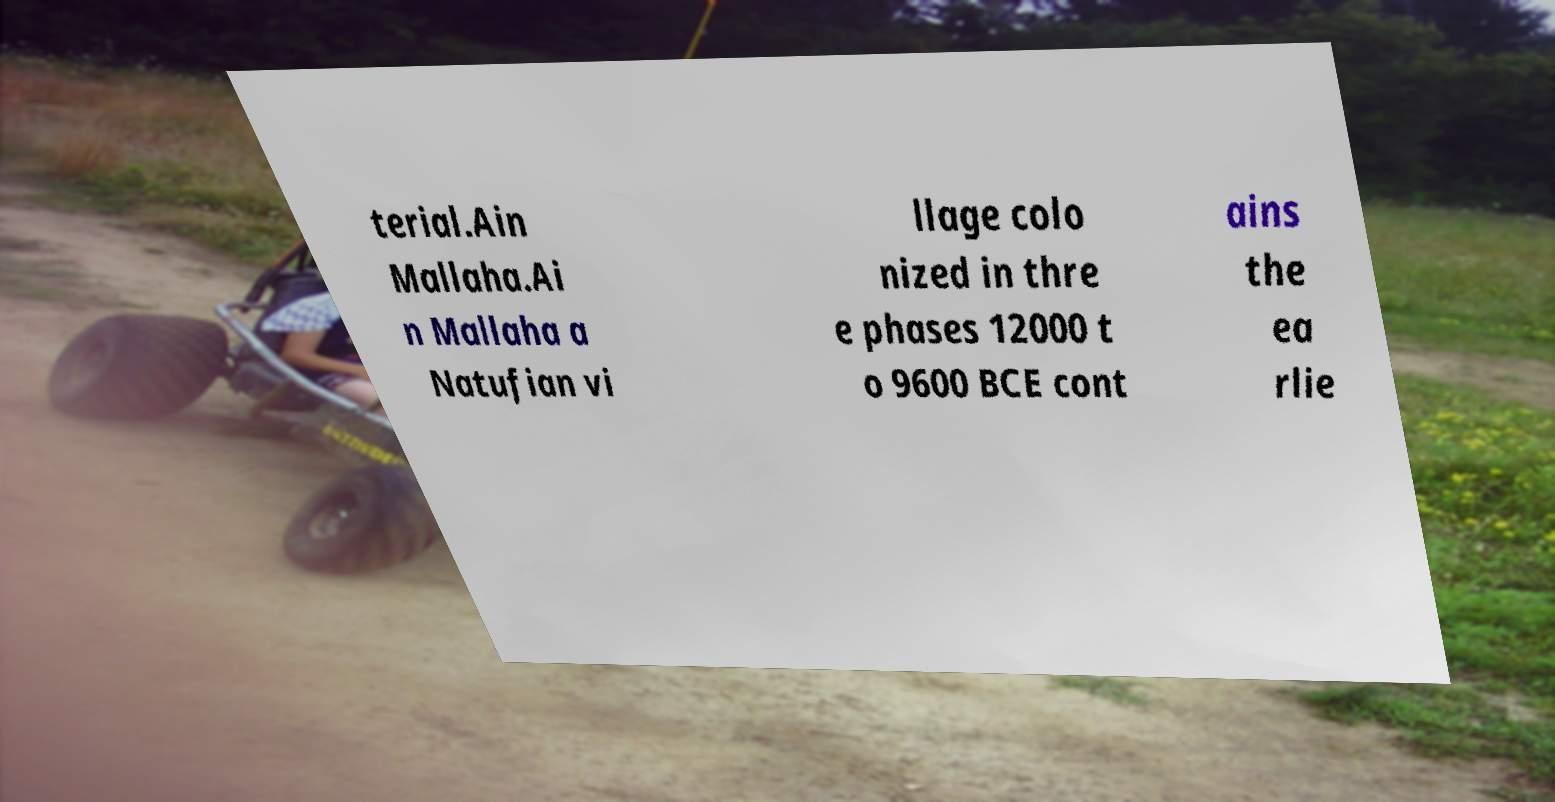Can you read and provide the text displayed in the image?This photo seems to have some interesting text. Can you extract and type it out for me? terial.Ain Mallaha.Ai n Mallaha a Natufian vi llage colo nized in thre e phases 12000 t o 9600 BCE cont ains the ea rlie 